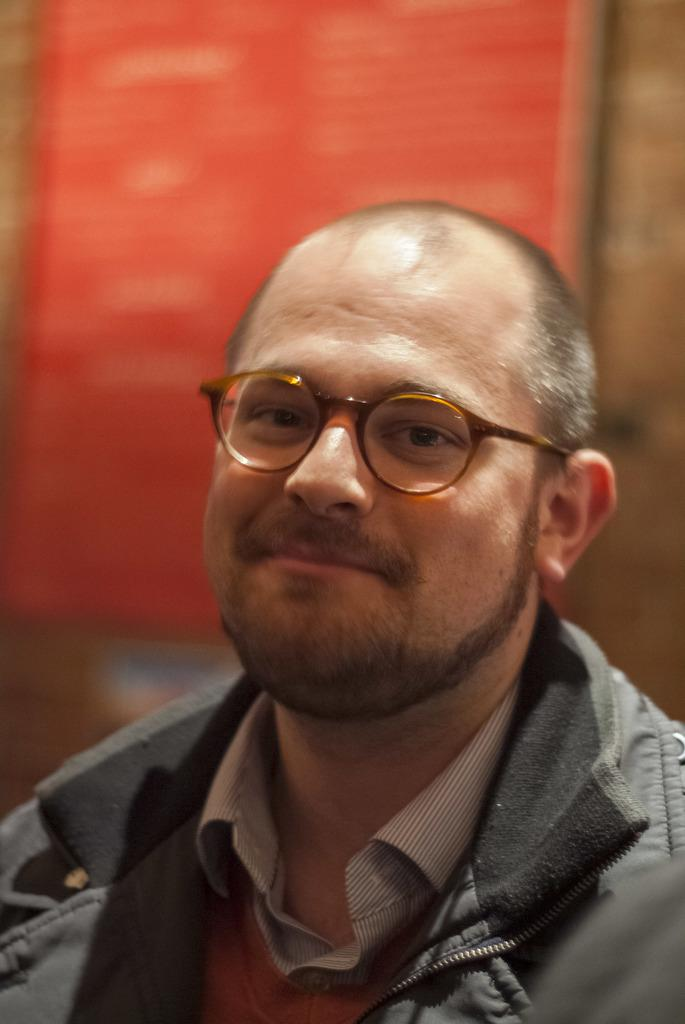What is the main subject of the image? There is a person in the image. What is the person wearing on their upper body? The person is wearing a white shirt and a black jacket. What accessory is the person wearing? The person is wearing spectacles. What is the person's facial expression? The person is smiling. What colors can be seen in the background of the image? The background of the image is brown and orange in color. What type of coat is the person wearing on their head in the image? There is no coat visible on the person's head in the image. 